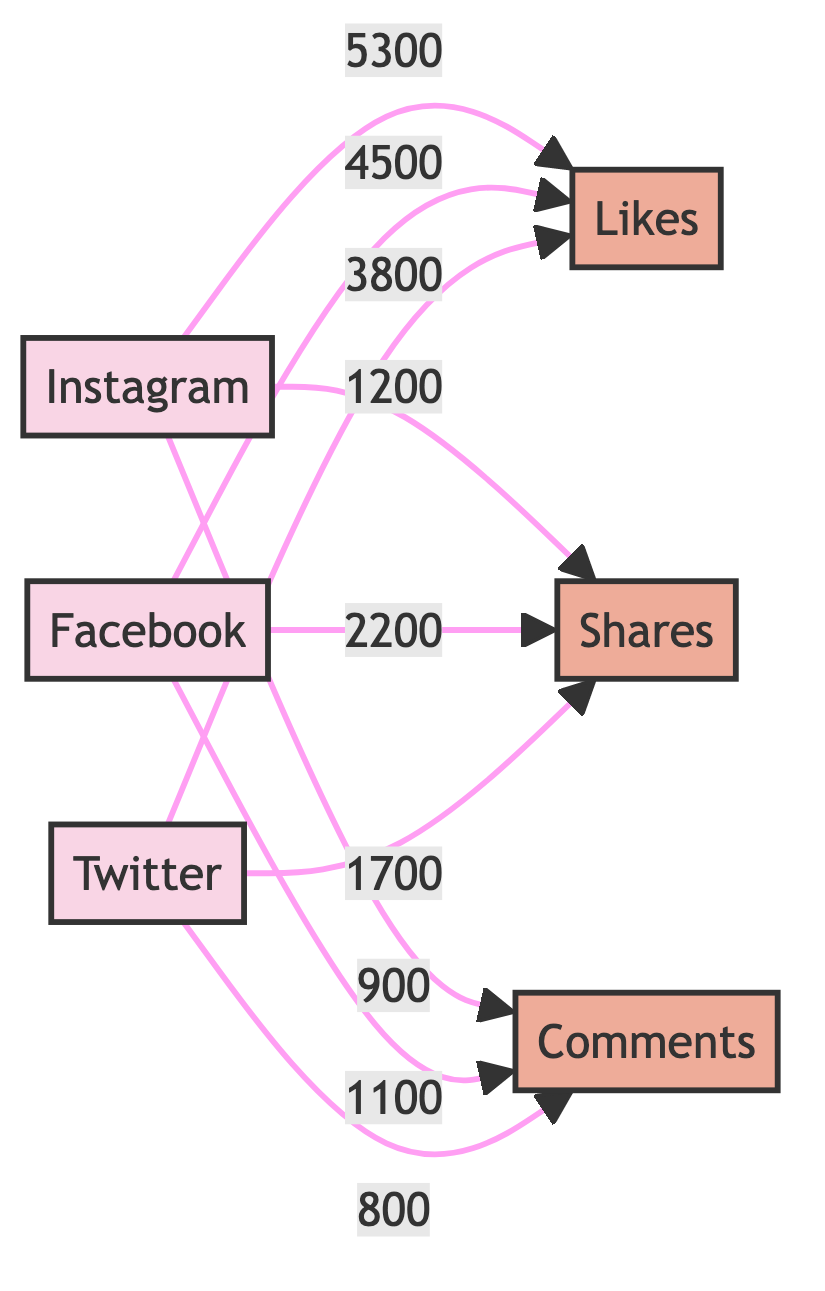What is the total number of likes across all platforms? To find the total number of likes, we add the likes for Instagram (5300), Facebook (4500), and Twitter (3800) together: 5300 + 4500 + 3800 = 13600.
Answer: 13600 Which platform has the highest number of shares? By comparing the shares of each platform, Instagram has 1200 shares, Facebook has 2200 shares, and Twitter has 1700 shares. Therefore, Facebook has the highest number of shares at 2200.
Answer: Facebook How many comments did Twitter receive? Looking at the diagram, Twitter shows a value of 800 under comments.
Answer: 800 What is the difference in likes between Instagram and Facebook? To find the difference, we subtract the number of likes for Instagram (5300) from Facebook (4500): 5300 - 4500 = 800.
Answer: 800 Which social media platform has the lowest number of comments? Comparing the comments: Instagram has 900, Facebook has 1100, and Twitter has 800. Twitter has the lowest number of comments at 800.
Answer: Twitter What are the total shares from Instagram and Twitter combined? We add the shares of Instagram (1200) and Twitter (1700): 1200 + 1700 = 2900.
Answer: 2900 What is the ratio of likes on Instagram to likes on Twitter? The number of likes on Instagram is 5300 and on Twitter is 3800. The ratio is calculated by dividing 5300 by 3800, which simplifies to approximately 1.39.
Answer: 1.39 How many nodes are there representing engagement metrics? The diagram represents three engagement metrics: likes, shares, and comments. Thus, there are three nodes for engagement metrics.
Answer: 3 Which platform has the highest engagement in total when combining likes, shares, and comments? The total engagement for each platform is calculated as follows: Instagram (5300 + 1200 + 900 = 7400), Facebook (4500 + 2200 + 1100 = 7800), Twitter (3800 + 1700 + 800 = 6300). Facebook has the highest total engagement at 7800.
Answer: Facebook 